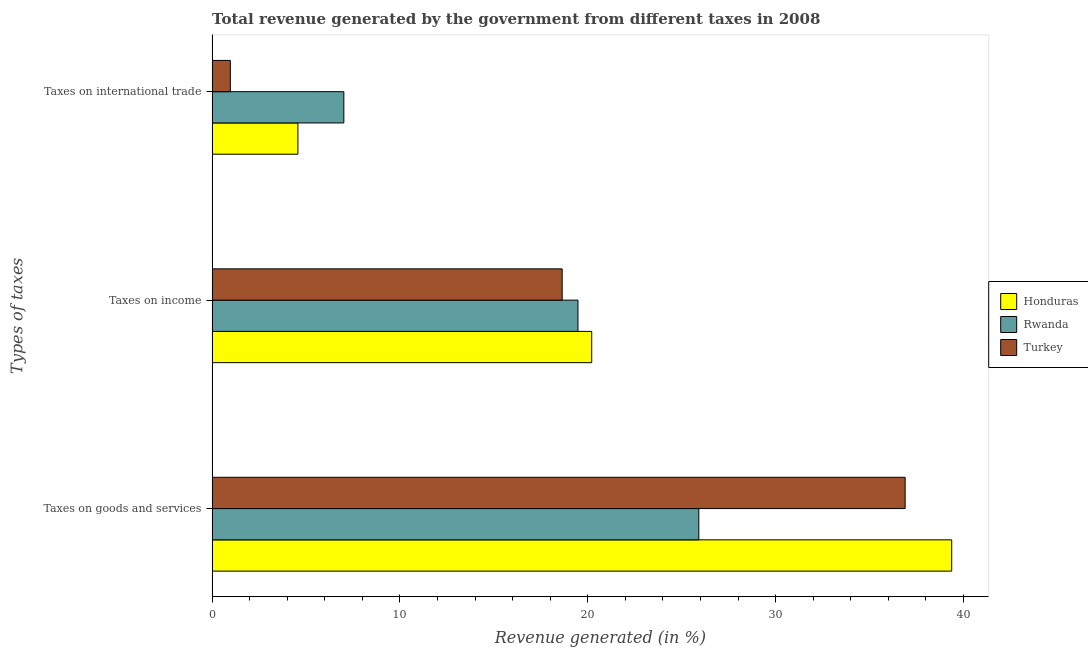How many different coloured bars are there?
Provide a succinct answer. 3. How many groups of bars are there?
Make the answer very short. 3. Are the number of bars per tick equal to the number of legend labels?
Provide a short and direct response. Yes. Are the number of bars on each tick of the Y-axis equal?
Keep it short and to the point. Yes. How many bars are there on the 3rd tick from the top?
Your answer should be very brief. 3. How many bars are there on the 2nd tick from the bottom?
Offer a very short reply. 3. What is the label of the 1st group of bars from the top?
Provide a short and direct response. Taxes on international trade. What is the percentage of revenue generated by taxes on income in Honduras?
Ensure brevity in your answer.  20.21. Across all countries, what is the maximum percentage of revenue generated by tax on international trade?
Give a very brief answer. 7.01. Across all countries, what is the minimum percentage of revenue generated by tax on international trade?
Provide a short and direct response. 0.97. In which country was the percentage of revenue generated by taxes on goods and services maximum?
Make the answer very short. Honduras. In which country was the percentage of revenue generated by tax on international trade minimum?
Your response must be concise. Turkey. What is the total percentage of revenue generated by taxes on goods and services in the graph?
Your answer should be compact. 102.18. What is the difference between the percentage of revenue generated by tax on international trade in Honduras and that in Turkey?
Your answer should be compact. 3.6. What is the difference between the percentage of revenue generated by taxes on goods and services in Turkey and the percentage of revenue generated by tax on international trade in Honduras?
Your response must be concise. 32.33. What is the average percentage of revenue generated by taxes on income per country?
Make the answer very short. 19.44. What is the difference between the percentage of revenue generated by taxes on income and percentage of revenue generated by tax on international trade in Turkey?
Your answer should be very brief. 17.67. What is the ratio of the percentage of revenue generated by taxes on income in Honduras to that in Turkey?
Your answer should be very brief. 1.08. Is the difference between the percentage of revenue generated by taxes on income in Rwanda and Turkey greater than the difference between the percentage of revenue generated by tax on international trade in Rwanda and Turkey?
Your answer should be very brief. No. What is the difference between the highest and the second highest percentage of revenue generated by taxes on income?
Keep it short and to the point. 0.73. What is the difference between the highest and the lowest percentage of revenue generated by tax on international trade?
Your answer should be compact. 6.04. In how many countries, is the percentage of revenue generated by taxes on income greater than the average percentage of revenue generated by taxes on income taken over all countries?
Offer a very short reply. 2. What does the 2nd bar from the top in Taxes on international trade represents?
Keep it short and to the point. Rwanda. What does the 3rd bar from the bottom in Taxes on goods and services represents?
Ensure brevity in your answer.  Turkey. Is it the case that in every country, the sum of the percentage of revenue generated by taxes on goods and services and percentage of revenue generated by taxes on income is greater than the percentage of revenue generated by tax on international trade?
Offer a very short reply. Yes. How many bars are there?
Offer a terse response. 9. What is the difference between two consecutive major ticks on the X-axis?
Ensure brevity in your answer.  10. Does the graph contain grids?
Provide a succinct answer. No. Where does the legend appear in the graph?
Offer a terse response. Center right. What is the title of the graph?
Provide a succinct answer. Total revenue generated by the government from different taxes in 2008. Does "Puerto Rico" appear as one of the legend labels in the graph?
Make the answer very short. No. What is the label or title of the X-axis?
Give a very brief answer. Revenue generated (in %). What is the label or title of the Y-axis?
Your answer should be compact. Types of taxes. What is the Revenue generated (in %) of Honduras in Taxes on goods and services?
Provide a succinct answer. 39.37. What is the Revenue generated (in %) of Rwanda in Taxes on goods and services?
Your answer should be very brief. 25.91. What is the Revenue generated (in %) of Turkey in Taxes on goods and services?
Your answer should be compact. 36.9. What is the Revenue generated (in %) of Honduras in Taxes on income?
Offer a very short reply. 20.21. What is the Revenue generated (in %) of Rwanda in Taxes on income?
Ensure brevity in your answer.  19.48. What is the Revenue generated (in %) of Turkey in Taxes on income?
Your response must be concise. 18.64. What is the Revenue generated (in %) in Honduras in Taxes on international trade?
Offer a very short reply. 4.57. What is the Revenue generated (in %) in Rwanda in Taxes on international trade?
Ensure brevity in your answer.  7.01. What is the Revenue generated (in %) of Turkey in Taxes on international trade?
Keep it short and to the point. 0.97. Across all Types of taxes, what is the maximum Revenue generated (in %) in Honduras?
Offer a terse response. 39.37. Across all Types of taxes, what is the maximum Revenue generated (in %) in Rwanda?
Provide a succinct answer. 25.91. Across all Types of taxes, what is the maximum Revenue generated (in %) in Turkey?
Provide a short and direct response. 36.9. Across all Types of taxes, what is the minimum Revenue generated (in %) in Honduras?
Offer a terse response. 4.57. Across all Types of taxes, what is the minimum Revenue generated (in %) in Rwanda?
Your answer should be very brief. 7.01. Across all Types of taxes, what is the minimum Revenue generated (in %) of Turkey?
Provide a succinct answer. 0.97. What is the total Revenue generated (in %) of Honduras in the graph?
Make the answer very short. 64.15. What is the total Revenue generated (in %) of Rwanda in the graph?
Provide a succinct answer. 52.4. What is the total Revenue generated (in %) of Turkey in the graph?
Make the answer very short. 56.5. What is the difference between the Revenue generated (in %) of Honduras in Taxes on goods and services and that in Taxes on income?
Provide a short and direct response. 19.17. What is the difference between the Revenue generated (in %) in Rwanda in Taxes on goods and services and that in Taxes on income?
Provide a short and direct response. 6.43. What is the difference between the Revenue generated (in %) of Turkey in Taxes on goods and services and that in Taxes on income?
Ensure brevity in your answer.  18.26. What is the difference between the Revenue generated (in %) of Honduras in Taxes on goods and services and that in Taxes on international trade?
Your answer should be compact. 34.81. What is the difference between the Revenue generated (in %) of Rwanda in Taxes on goods and services and that in Taxes on international trade?
Ensure brevity in your answer.  18.9. What is the difference between the Revenue generated (in %) of Turkey in Taxes on goods and services and that in Taxes on international trade?
Your answer should be compact. 35.93. What is the difference between the Revenue generated (in %) in Honduras in Taxes on income and that in Taxes on international trade?
Your response must be concise. 15.64. What is the difference between the Revenue generated (in %) in Rwanda in Taxes on income and that in Taxes on international trade?
Your answer should be very brief. 12.46. What is the difference between the Revenue generated (in %) in Turkey in Taxes on income and that in Taxes on international trade?
Make the answer very short. 17.67. What is the difference between the Revenue generated (in %) of Honduras in Taxes on goods and services and the Revenue generated (in %) of Rwanda in Taxes on income?
Keep it short and to the point. 19.9. What is the difference between the Revenue generated (in %) in Honduras in Taxes on goods and services and the Revenue generated (in %) in Turkey in Taxes on income?
Your answer should be compact. 20.74. What is the difference between the Revenue generated (in %) in Rwanda in Taxes on goods and services and the Revenue generated (in %) in Turkey in Taxes on income?
Offer a very short reply. 7.28. What is the difference between the Revenue generated (in %) of Honduras in Taxes on goods and services and the Revenue generated (in %) of Rwanda in Taxes on international trade?
Keep it short and to the point. 32.36. What is the difference between the Revenue generated (in %) of Honduras in Taxes on goods and services and the Revenue generated (in %) of Turkey in Taxes on international trade?
Your answer should be very brief. 38.41. What is the difference between the Revenue generated (in %) in Rwanda in Taxes on goods and services and the Revenue generated (in %) in Turkey in Taxes on international trade?
Give a very brief answer. 24.94. What is the difference between the Revenue generated (in %) in Honduras in Taxes on income and the Revenue generated (in %) in Rwanda in Taxes on international trade?
Keep it short and to the point. 13.2. What is the difference between the Revenue generated (in %) of Honduras in Taxes on income and the Revenue generated (in %) of Turkey in Taxes on international trade?
Offer a very short reply. 19.24. What is the difference between the Revenue generated (in %) in Rwanda in Taxes on income and the Revenue generated (in %) in Turkey in Taxes on international trade?
Ensure brevity in your answer.  18.51. What is the average Revenue generated (in %) in Honduras per Types of taxes?
Make the answer very short. 21.38. What is the average Revenue generated (in %) in Rwanda per Types of taxes?
Your answer should be compact. 17.47. What is the average Revenue generated (in %) in Turkey per Types of taxes?
Offer a terse response. 18.83. What is the difference between the Revenue generated (in %) in Honduras and Revenue generated (in %) in Rwanda in Taxes on goods and services?
Your answer should be compact. 13.46. What is the difference between the Revenue generated (in %) of Honduras and Revenue generated (in %) of Turkey in Taxes on goods and services?
Make the answer very short. 2.48. What is the difference between the Revenue generated (in %) of Rwanda and Revenue generated (in %) of Turkey in Taxes on goods and services?
Offer a terse response. -10.98. What is the difference between the Revenue generated (in %) of Honduras and Revenue generated (in %) of Rwanda in Taxes on income?
Your answer should be compact. 0.73. What is the difference between the Revenue generated (in %) of Honduras and Revenue generated (in %) of Turkey in Taxes on income?
Offer a terse response. 1.57. What is the difference between the Revenue generated (in %) of Rwanda and Revenue generated (in %) of Turkey in Taxes on income?
Ensure brevity in your answer.  0.84. What is the difference between the Revenue generated (in %) of Honduras and Revenue generated (in %) of Rwanda in Taxes on international trade?
Make the answer very short. -2.45. What is the difference between the Revenue generated (in %) of Honduras and Revenue generated (in %) of Turkey in Taxes on international trade?
Give a very brief answer. 3.6. What is the difference between the Revenue generated (in %) of Rwanda and Revenue generated (in %) of Turkey in Taxes on international trade?
Give a very brief answer. 6.04. What is the ratio of the Revenue generated (in %) of Honduras in Taxes on goods and services to that in Taxes on income?
Your response must be concise. 1.95. What is the ratio of the Revenue generated (in %) in Rwanda in Taxes on goods and services to that in Taxes on income?
Your response must be concise. 1.33. What is the ratio of the Revenue generated (in %) in Turkey in Taxes on goods and services to that in Taxes on income?
Provide a succinct answer. 1.98. What is the ratio of the Revenue generated (in %) in Honduras in Taxes on goods and services to that in Taxes on international trade?
Make the answer very short. 8.62. What is the ratio of the Revenue generated (in %) of Rwanda in Taxes on goods and services to that in Taxes on international trade?
Offer a very short reply. 3.69. What is the ratio of the Revenue generated (in %) in Turkey in Taxes on goods and services to that in Taxes on international trade?
Provide a short and direct response. 38.05. What is the ratio of the Revenue generated (in %) of Honduras in Taxes on income to that in Taxes on international trade?
Ensure brevity in your answer.  4.42. What is the ratio of the Revenue generated (in %) in Rwanda in Taxes on income to that in Taxes on international trade?
Your answer should be compact. 2.78. What is the ratio of the Revenue generated (in %) of Turkey in Taxes on income to that in Taxes on international trade?
Make the answer very short. 19.22. What is the difference between the highest and the second highest Revenue generated (in %) of Honduras?
Make the answer very short. 19.17. What is the difference between the highest and the second highest Revenue generated (in %) in Rwanda?
Your answer should be very brief. 6.43. What is the difference between the highest and the second highest Revenue generated (in %) of Turkey?
Keep it short and to the point. 18.26. What is the difference between the highest and the lowest Revenue generated (in %) of Honduras?
Give a very brief answer. 34.81. What is the difference between the highest and the lowest Revenue generated (in %) in Rwanda?
Your answer should be very brief. 18.9. What is the difference between the highest and the lowest Revenue generated (in %) in Turkey?
Offer a terse response. 35.93. 